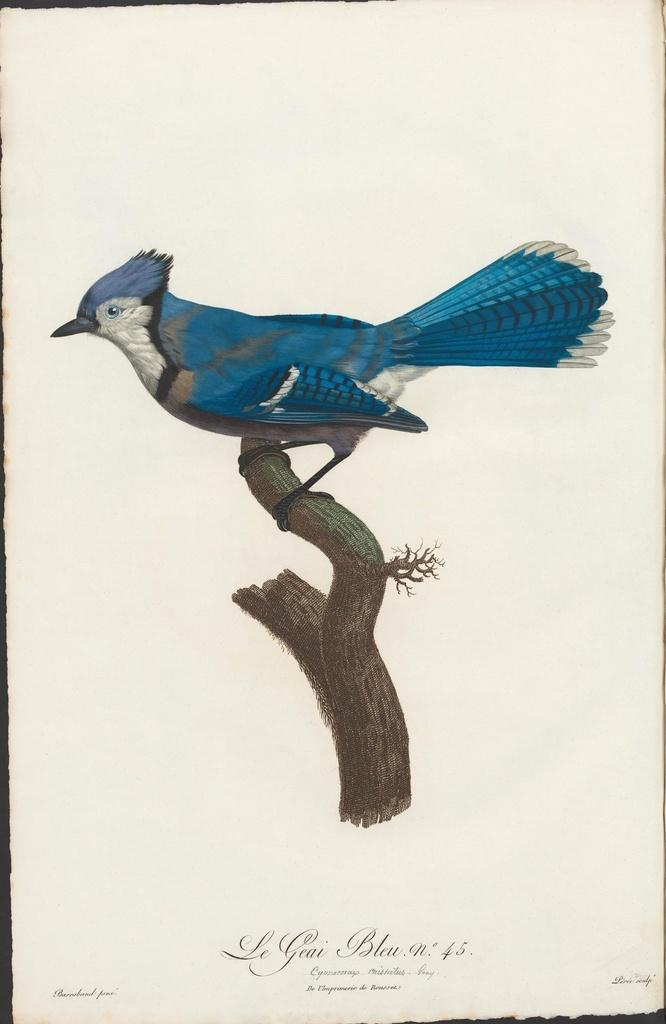What is the main subject of the image? There is a painting in the image. What is depicted in the painting? The painting depicts a bird on the branch of a tree. Is there any text associated with the painting? Yes, there is some text at the bottom of the painting. How many seeds can be seen falling from the tree in the painting? There are no seeds visible in the painting; it depicts a bird on the branch of a tree. What type of stone is used as a prop for the bird in the painting? There is no stone present in the painting; it features a bird on the branch of a tree. 